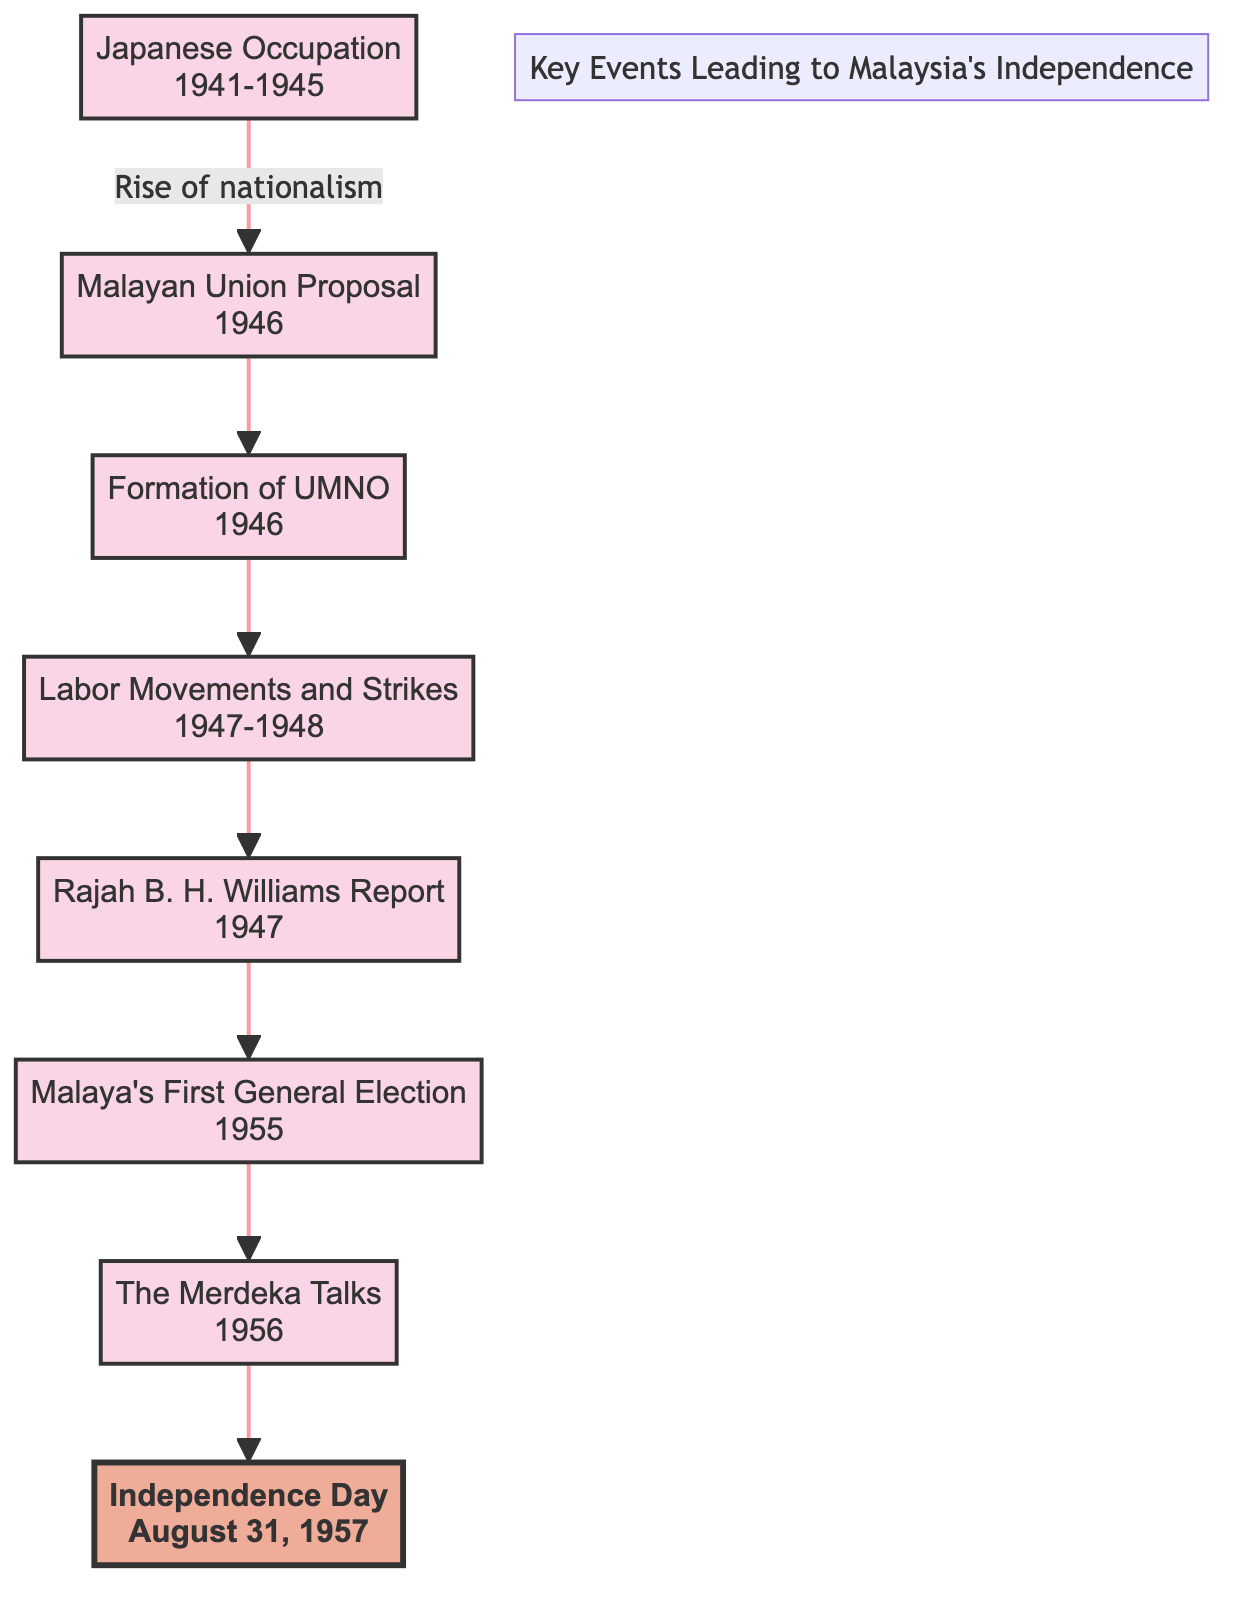What event occurs immediately after the Japanese Occupation? According to the flowchart, the event that follows the Japanese Occupation (1941-1945) is the Malayan Union Proposal (1946), as indicated by the arrow connecting these two nodes.
Answer: Malayan Union Proposal Which political party was formed in 1946? The diagram shows that in 1946, the Formation of UMNO is highlighted as an event, which indicates that the United Malays National Organization was established in that year.
Answer: UMNO How many years were there between the Japanese Occupation and Independence Day? The diagram indicates that the Japanese Occupation ended in 1945 and Independence Day is in 1957. Calculating the difference yields 1957 - 1945, which is 12 years.
Answer: 12 What significant event occurred in 1956? Looking at the flowchart, the event listed for 1956 is "The Merdeka Talks," which involved discussions for Malaysia’s independence.
Answer: The Merdeka Talks What led to the rise of nationalism? The flowchart states that the Japanese Occupation (1941-1945) led to a rise in nationalist sentiments, establishing a clear cause for the subsequent events.
Answer: Japanese Occupation What was the report issued in 1947 that influenced independence discussions? In the diagram, the Rajah B. H. Williams Report (1947) is noted as a significant document proposing a form of self-government and influencing discussions regarding independence.
Answer: Rajah B. H. Williams Report What milestone event is shown at the end of the diagram? The final node in the flowchart is "Independence Day" on August 31, 1957, indicating the milestone of Malaya gaining independence from British rule.
Answer: Independence Day Which event reflects significant political changes and the emergence of autonomy movements? The flowchart identifies “Malaya’s First General Election” in 1955 as the event that led to significant political changes and the rise of autonomy movements.
Answer: Malaya's First General Election How many total events are represented in the flowchart? By counting all the distinct events displayed in the flowchart, including the nodes until the final milestone, we find there are a total of 8 events.
Answer: 8 